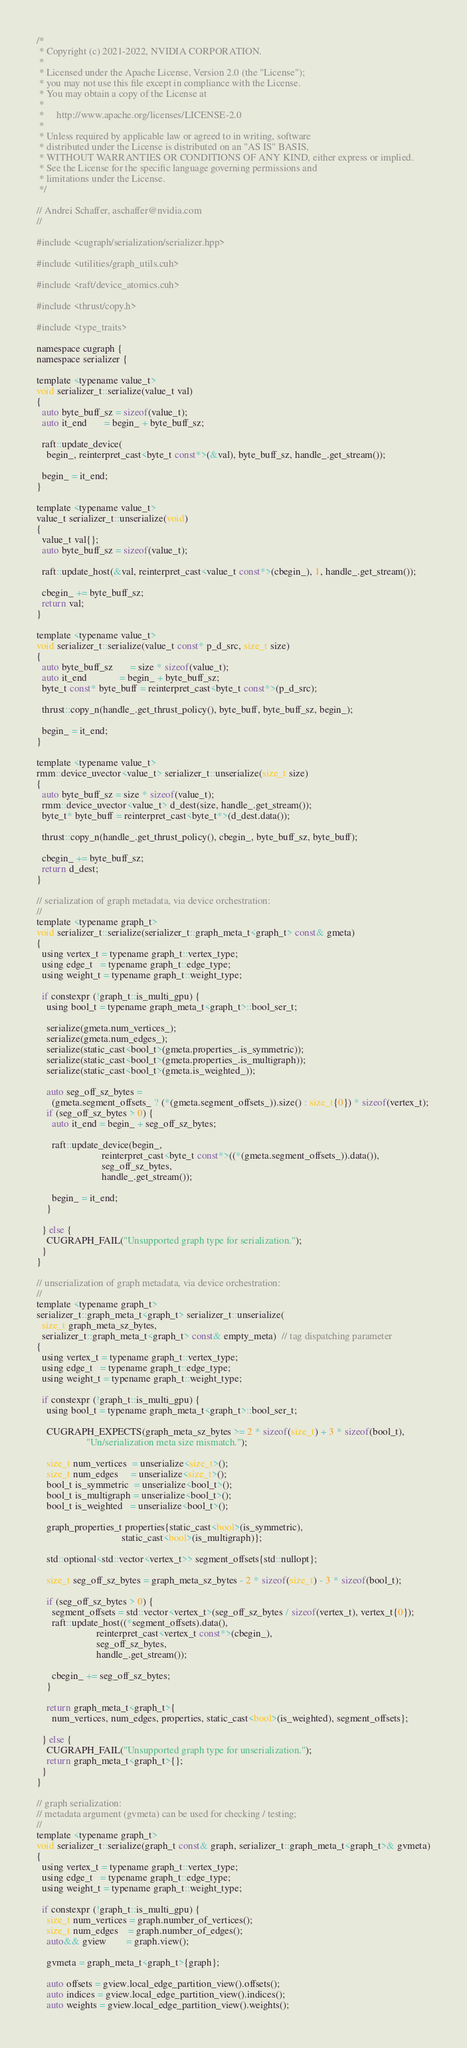Convert code to text. <code><loc_0><loc_0><loc_500><loc_500><_Cuda_>/*
 * Copyright (c) 2021-2022, NVIDIA CORPORATION.
 *
 * Licensed under the Apache License, Version 2.0 (the "License");
 * you may not use this file except in compliance with the License.
 * You may obtain a copy of the License at
 *
 *     http://www.apache.org/licenses/LICENSE-2.0
 *
 * Unless required by applicable law or agreed to in writing, software
 * distributed under the License is distributed on an "AS IS" BASIS,
 * WITHOUT WARRANTIES OR CONDITIONS OF ANY KIND, either express or implied.
 * See the License for the specific language governing permissions and
 * limitations under the License.
 */

// Andrei Schaffer, aschaffer@nvidia.com
//

#include <cugraph/serialization/serializer.hpp>

#include <utilities/graph_utils.cuh>

#include <raft/device_atomics.cuh>

#include <thrust/copy.h>

#include <type_traits>

namespace cugraph {
namespace serializer {

template <typename value_t>
void serializer_t::serialize(value_t val)
{
  auto byte_buff_sz = sizeof(value_t);
  auto it_end       = begin_ + byte_buff_sz;

  raft::update_device(
    begin_, reinterpret_cast<byte_t const*>(&val), byte_buff_sz, handle_.get_stream());

  begin_ = it_end;
}

template <typename value_t>
value_t serializer_t::unserialize(void)
{
  value_t val{};
  auto byte_buff_sz = sizeof(value_t);

  raft::update_host(&val, reinterpret_cast<value_t const*>(cbegin_), 1, handle_.get_stream());

  cbegin_ += byte_buff_sz;
  return val;
}

template <typename value_t>
void serializer_t::serialize(value_t const* p_d_src, size_t size)
{
  auto byte_buff_sz       = size * sizeof(value_t);
  auto it_end             = begin_ + byte_buff_sz;
  byte_t const* byte_buff = reinterpret_cast<byte_t const*>(p_d_src);

  thrust::copy_n(handle_.get_thrust_policy(), byte_buff, byte_buff_sz, begin_);

  begin_ = it_end;
}

template <typename value_t>
rmm::device_uvector<value_t> serializer_t::unserialize(size_t size)
{
  auto byte_buff_sz = size * sizeof(value_t);
  rmm::device_uvector<value_t> d_dest(size, handle_.get_stream());
  byte_t* byte_buff = reinterpret_cast<byte_t*>(d_dest.data());

  thrust::copy_n(handle_.get_thrust_policy(), cbegin_, byte_buff_sz, byte_buff);

  cbegin_ += byte_buff_sz;
  return d_dest;
}

// serialization of graph metadata, via device orchestration:
//
template <typename graph_t>
void serializer_t::serialize(serializer_t::graph_meta_t<graph_t> const& gmeta)
{
  using vertex_t = typename graph_t::vertex_type;
  using edge_t   = typename graph_t::edge_type;
  using weight_t = typename graph_t::weight_type;

  if constexpr (!graph_t::is_multi_gpu) {
    using bool_t = typename graph_meta_t<graph_t>::bool_ser_t;

    serialize(gmeta.num_vertices_);
    serialize(gmeta.num_edges_);
    serialize(static_cast<bool_t>(gmeta.properties_.is_symmetric));
    serialize(static_cast<bool_t>(gmeta.properties_.is_multigraph));
    serialize(static_cast<bool_t>(gmeta.is_weighted_));

    auto seg_off_sz_bytes =
      (gmeta.segment_offsets_ ? (*(gmeta.segment_offsets_)).size() : size_t{0}) * sizeof(vertex_t);
    if (seg_off_sz_bytes > 0) {
      auto it_end = begin_ + seg_off_sz_bytes;

      raft::update_device(begin_,
                          reinterpret_cast<byte_t const*>((*(gmeta.segment_offsets_)).data()),
                          seg_off_sz_bytes,
                          handle_.get_stream());

      begin_ = it_end;
    }

  } else {
    CUGRAPH_FAIL("Unsupported graph type for serialization.");
  }
}

// unserialization of graph metadata, via device orchestration:
//
template <typename graph_t>
serializer_t::graph_meta_t<graph_t> serializer_t::unserialize(
  size_t graph_meta_sz_bytes,
  serializer_t::graph_meta_t<graph_t> const& empty_meta)  // tag dispatching parameter
{
  using vertex_t = typename graph_t::vertex_type;
  using edge_t   = typename graph_t::edge_type;
  using weight_t = typename graph_t::weight_type;

  if constexpr (!graph_t::is_multi_gpu) {
    using bool_t = typename graph_meta_t<graph_t>::bool_ser_t;

    CUGRAPH_EXPECTS(graph_meta_sz_bytes >= 2 * sizeof(size_t) + 3 * sizeof(bool_t),
                    "Un/serialization meta size mismatch.");

    size_t num_vertices  = unserialize<size_t>();
    size_t num_edges     = unserialize<size_t>();
    bool_t is_symmetric  = unserialize<bool_t>();
    bool_t is_multigraph = unserialize<bool_t>();
    bool_t is_weighted   = unserialize<bool_t>();

    graph_properties_t properties{static_cast<bool>(is_symmetric),
                                  static_cast<bool>(is_multigraph)};

    std::optional<std::vector<vertex_t>> segment_offsets{std::nullopt};

    size_t seg_off_sz_bytes = graph_meta_sz_bytes - 2 * sizeof(size_t) - 3 * sizeof(bool_t);

    if (seg_off_sz_bytes > 0) {
      segment_offsets = std::vector<vertex_t>(seg_off_sz_bytes / sizeof(vertex_t), vertex_t{0});
      raft::update_host((*segment_offsets).data(),
                        reinterpret_cast<vertex_t const*>(cbegin_),
                        seg_off_sz_bytes,
                        handle_.get_stream());

      cbegin_ += seg_off_sz_bytes;
    }

    return graph_meta_t<graph_t>{
      num_vertices, num_edges, properties, static_cast<bool>(is_weighted), segment_offsets};

  } else {
    CUGRAPH_FAIL("Unsupported graph type for unserialization.");
    return graph_meta_t<graph_t>{};
  }
}

// graph serialization:
// metadata argument (gvmeta) can be used for checking / testing;
//
template <typename graph_t>
void serializer_t::serialize(graph_t const& graph, serializer_t::graph_meta_t<graph_t>& gvmeta)
{
  using vertex_t = typename graph_t::vertex_type;
  using edge_t   = typename graph_t::edge_type;
  using weight_t = typename graph_t::weight_type;

  if constexpr (!graph_t::is_multi_gpu) {
    size_t num_vertices = graph.number_of_vertices();
    size_t num_edges    = graph.number_of_edges();
    auto&& gview        = graph.view();

    gvmeta = graph_meta_t<graph_t>{graph};

    auto offsets = gview.local_edge_partition_view().offsets();
    auto indices = gview.local_edge_partition_view().indices();
    auto weights = gview.local_edge_partition_view().weights();
</code> 